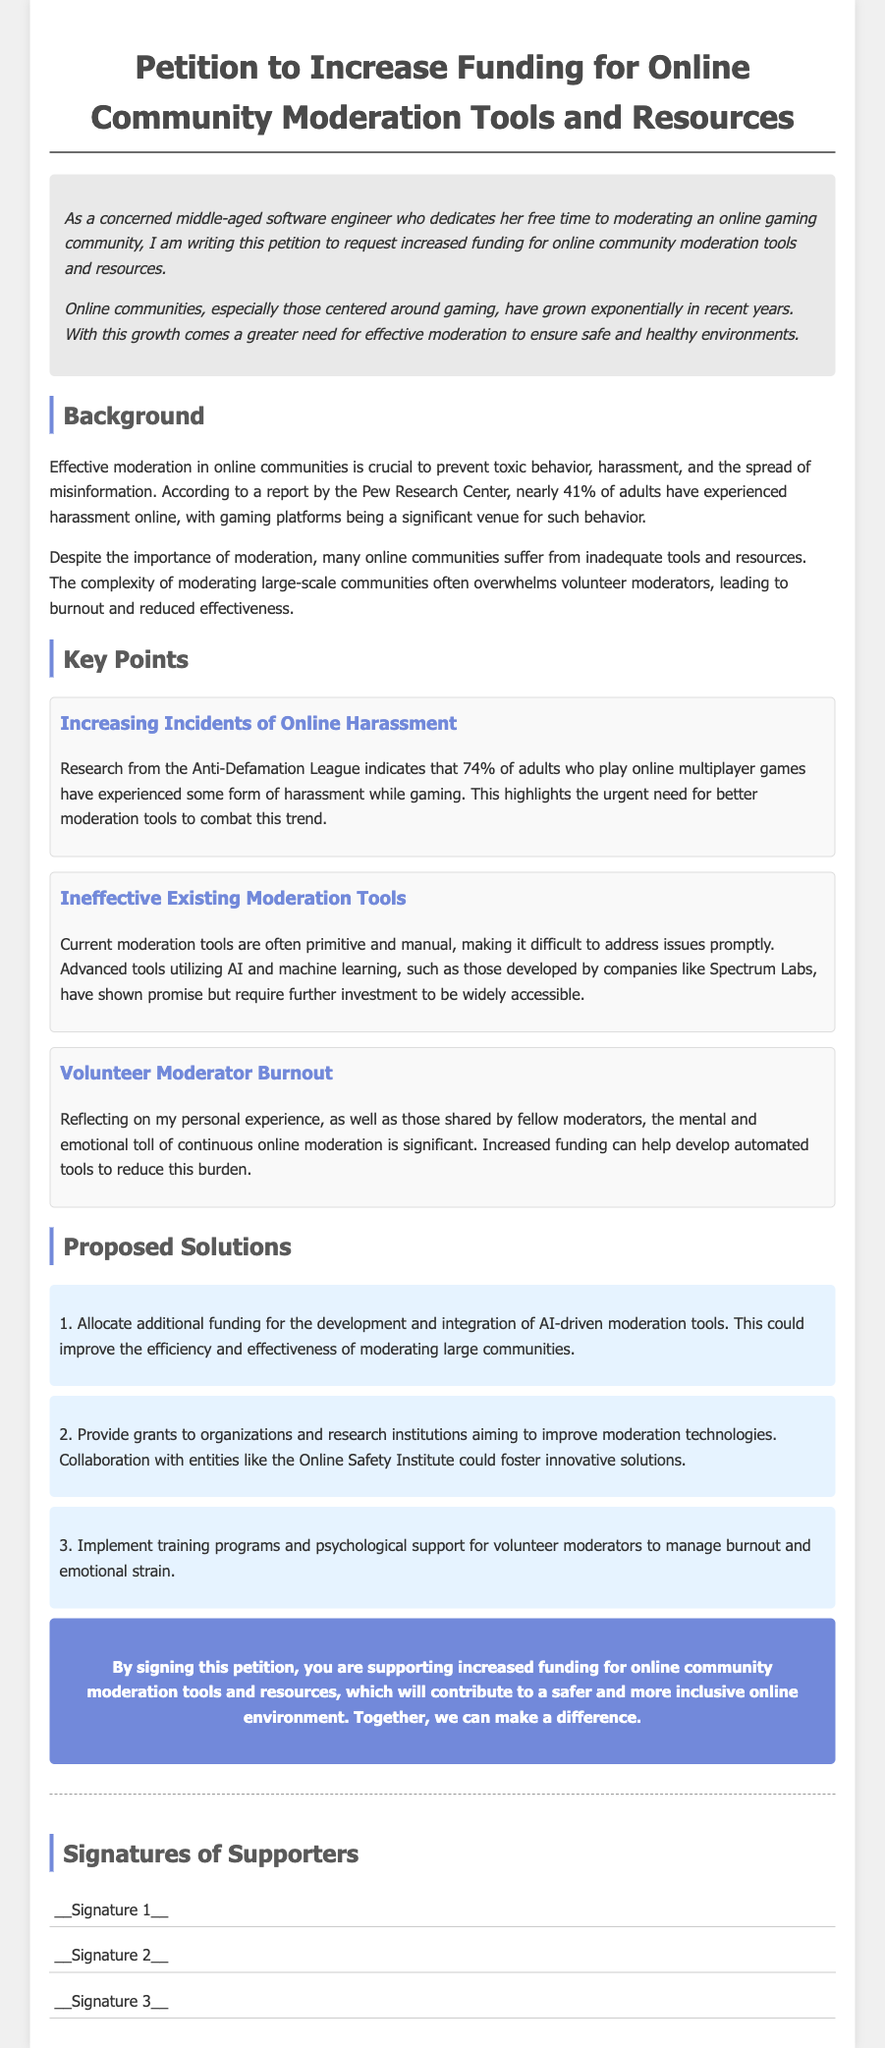What is the title of the petition? The title of the petition is the main heading that addresses the request being made in the document.
Answer: Petition to Increase Funding for Online Community Moderation Tools and Resources What percentage of adults have experienced online harassment according to Pew Research Center? The percentage is stated as a statistic in the document that reflects the prevalence of online harassment.
Answer: 41% Which organization provided research indicating that 74% of adult gamers experience harassment? The organization is mentioned in the key points section discussing harassment trends in gaming communities.
Answer: Anti-Defamation League What is one proposed solution for improving online moderation tools? The proposed solutions are listed, and this one addresses the development of new technologies for moderation.
Answer: Allocate additional funding for the development and integration of AI-driven moderation tools What is a key issue mentioned that affects volunteer moderators? The document discusses several challenges faced by volunteer moderators, indicating a significant consequence of their role in community management.
Answer: Burnout How does the petition propose to assist volunteer moderators? The document outlines various solutions, including one aimed specifically at supporting moderators emotionally.
Answer: Implement training programs and psychological support What type of document is this? The document follows a specific format that is aimed at gathering support for a cause or initiative, focusing on community improvement.
Answer: Petition What color is used for the conclusion section background? The background color used for the conclusion section is a specific visual element that adds emphasis to that part of the document.
Answer: #7289da 